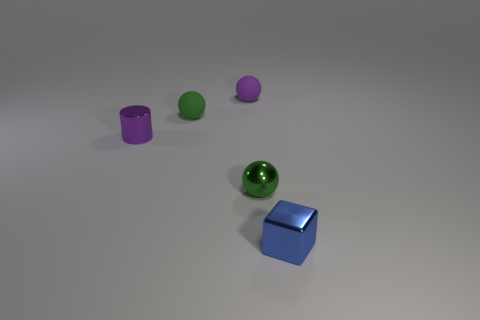Add 1 blue objects. How many objects exist? 6 Subtract all spheres. How many objects are left? 2 Add 4 green rubber objects. How many green rubber objects are left? 5 Add 4 small objects. How many small objects exist? 9 Subtract 0 brown balls. How many objects are left? 5 Subtract all red matte spheres. Subtract all small metal things. How many objects are left? 2 